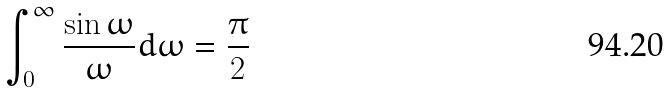<formula> <loc_0><loc_0><loc_500><loc_500>\int _ { 0 } ^ { \infty } \frac { \sin \omega } { \omega } d \omega = \frac { \pi } { 2 }</formula> 